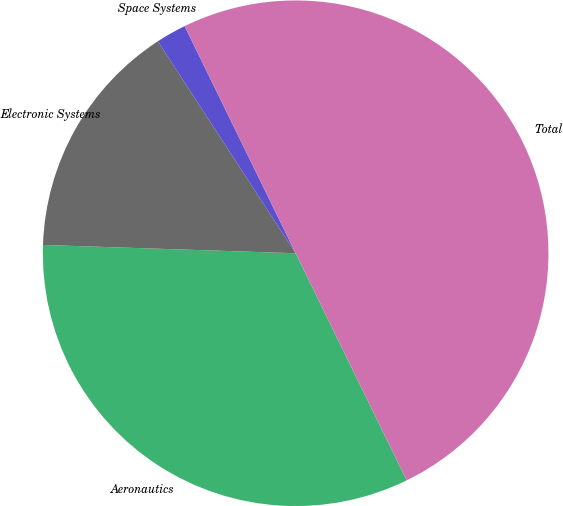Convert chart to OTSL. <chart><loc_0><loc_0><loc_500><loc_500><pie_chart><fcel>Aeronautics<fcel>Electronic Systems<fcel>Space Systems<fcel>Total<nl><fcel>32.76%<fcel>15.3%<fcel>1.94%<fcel>50.0%<nl></chart> 